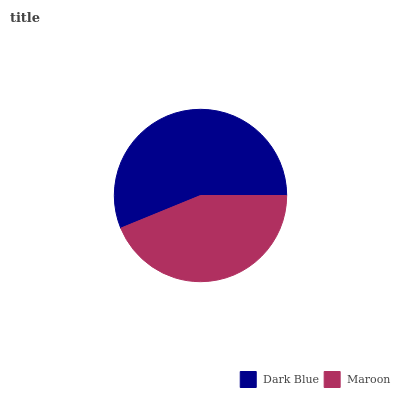Is Maroon the minimum?
Answer yes or no. Yes. Is Dark Blue the maximum?
Answer yes or no. Yes. Is Maroon the maximum?
Answer yes or no. No. Is Dark Blue greater than Maroon?
Answer yes or no. Yes. Is Maroon less than Dark Blue?
Answer yes or no. Yes. Is Maroon greater than Dark Blue?
Answer yes or no. No. Is Dark Blue less than Maroon?
Answer yes or no. No. Is Dark Blue the high median?
Answer yes or no. Yes. Is Maroon the low median?
Answer yes or no. Yes. Is Maroon the high median?
Answer yes or no. No. Is Dark Blue the low median?
Answer yes or no. No. 